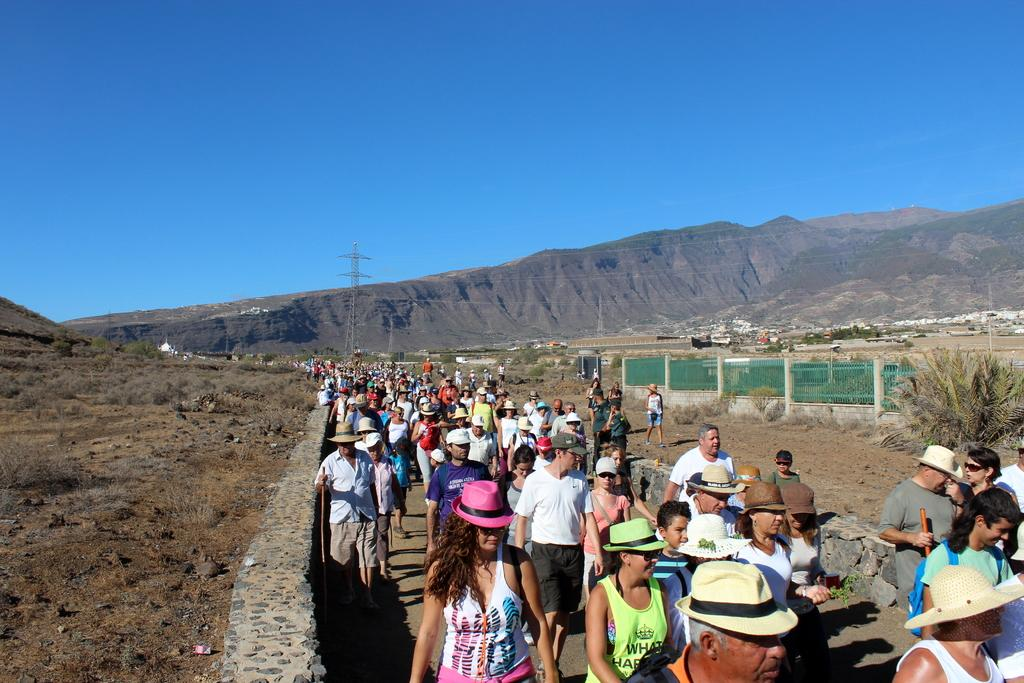What is happening in the image? There is a group of people standing in the image. What type of structures can be seen in the image? There are iron grilles in the image. What type of natural elements are present in the image? There are trees and hills in the image. What type of man-made structures are visible in the image? Cell towers are visible in the image. What type of infrastructure is present in the image? Cables are present in the image. What is visible in the background of the image? The sky is visible in the background of the image. What type of advertisement can be seen on the kettle in the image? There is no kettle present in the image, so there cannot be an advertisement on it. How many people can hear the conversation in the image? The image does not provide information about the ability to hear a conversation, so it cannot be determined. 